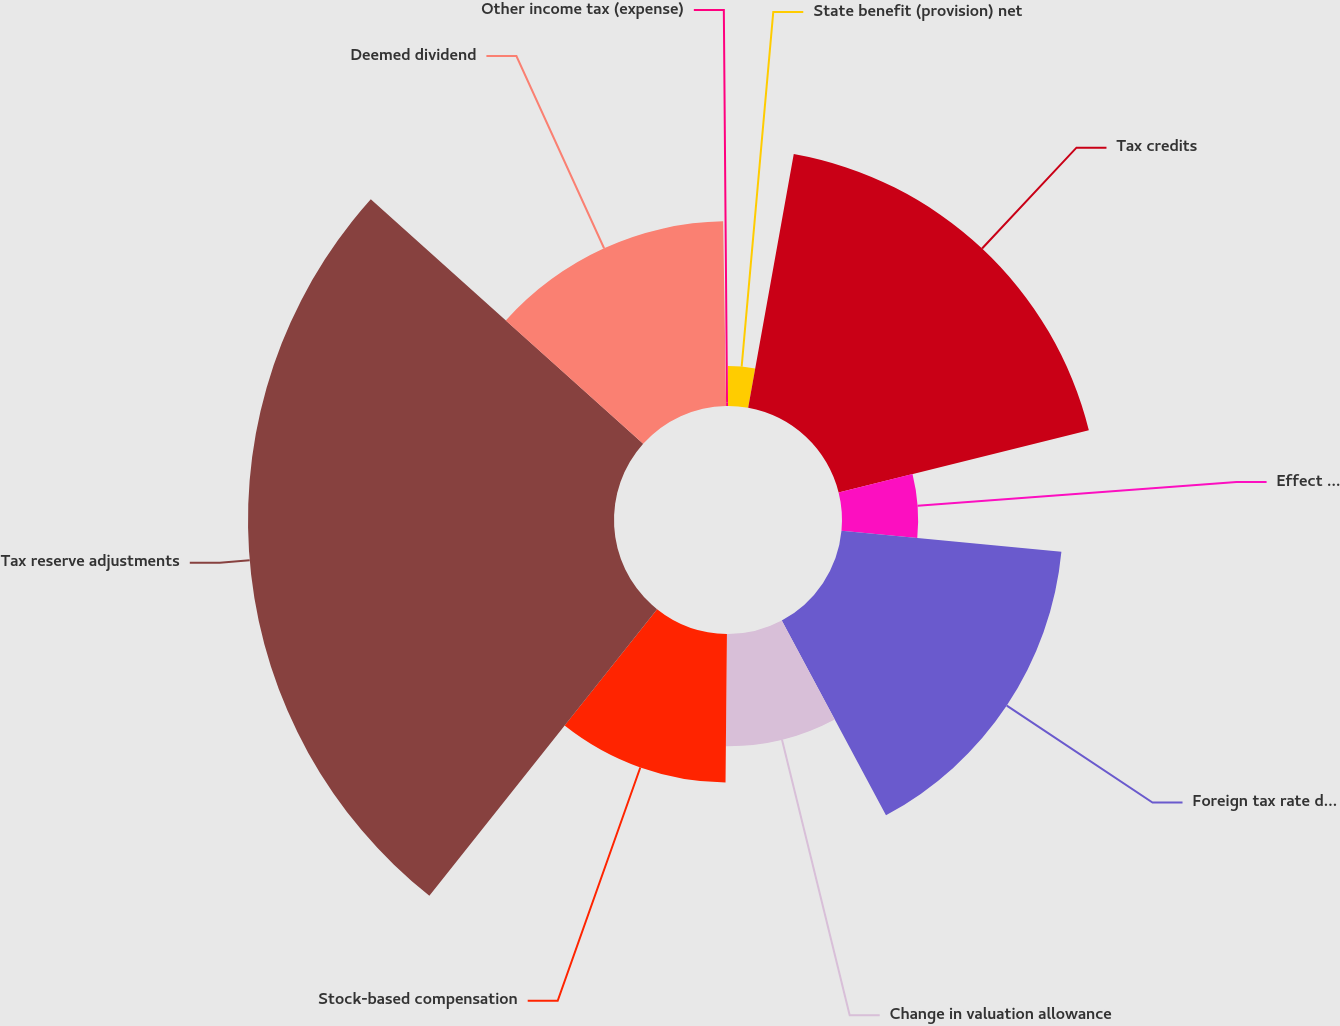Convert chart to OTSL. <chart><loc_0><loc_0><loc_500><loc_500><pie_chart><fcel>State benefit (provision) net<fcel>Tax credits<fcel>Effect of changes in income<fcel>Foreign tax rate difference<fcel>Change in valuation allowance<fcel>Stock-based compensation<fcel>Tax reserve adjustments<fcel>Deemed dividend<fcel>Other income tax (expense)<nl><fcel>2.83%<fcel>18.29%<fcel>5.4%<fcel>15.67%<fcel>7.97%<fcel>10.54%<fcel>25.96%<fcel>13.1%<fcel>0.26%<nl></chart> 